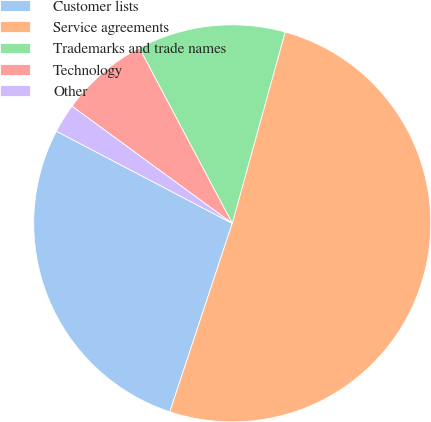Convert chart to OTSL. <chart><loc_0><loc_0><loc_500><loc_500><pie_chart><fcel>Customer lists<fcel>Service agreements<fcel>Trademarks and trade names<fcel>Technology<fcel>Other<nl><fcel>27.6%<fcel>50.8%<fcel>12.05%<fcel>7.2%<fcel>2.36%<nl></chart> 